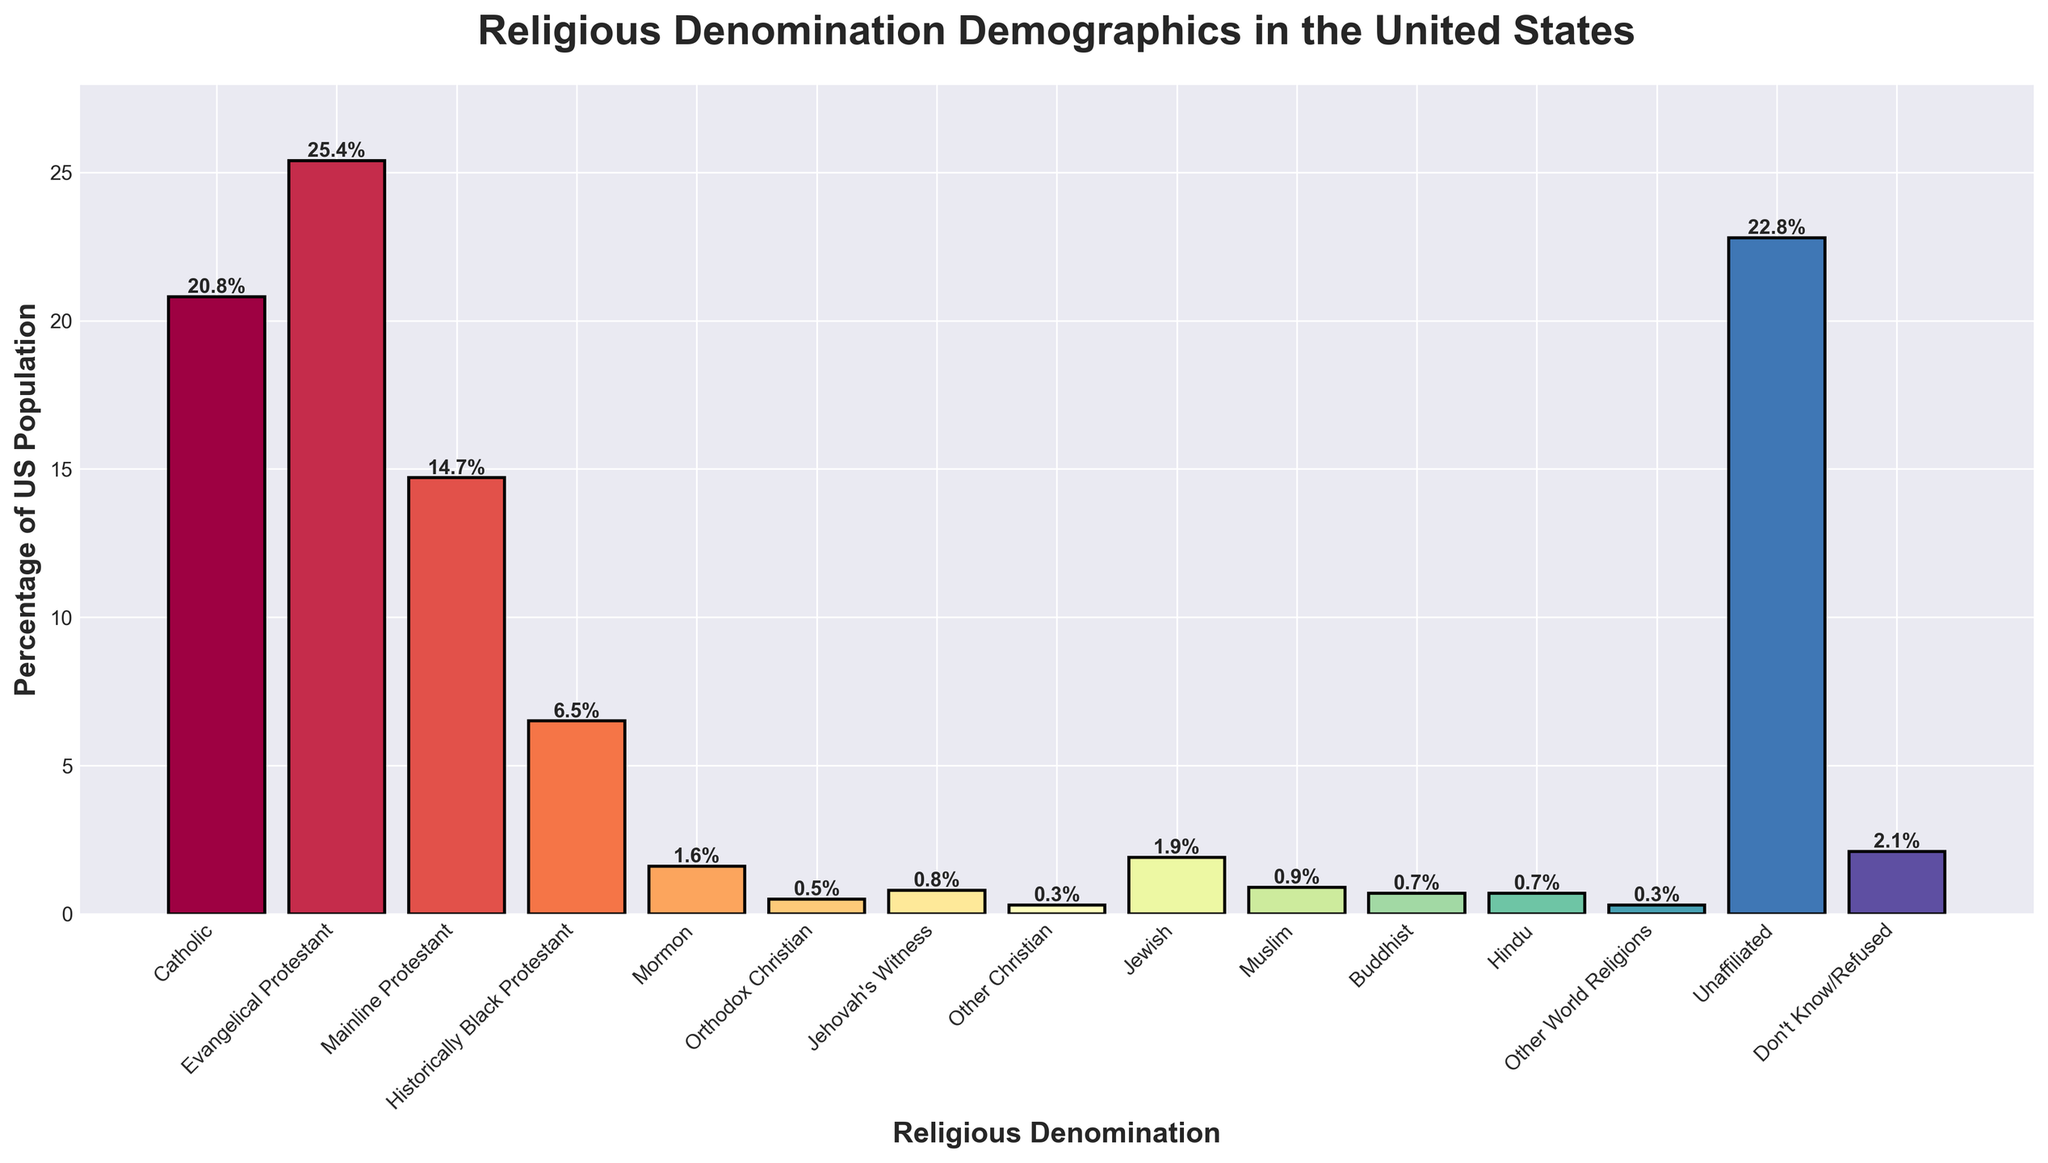What is the most common religious denomination in the United States? The bar with the highest value represents the most common denomination. From the chart, the "Evangelical Protestant" bar has the highest percentage.
Answer: Evangelical Protestant Which denomination has a slightly lower percentage than Catholic? Locate the bar for Catholic and observe the adjacent bars. The "Unaffiliated" category is quite close but marginally lower than Catholic at 22.8%.
Answer: Unaffiliated What is the total percentage of US population represented by Evangelical Protestant, Mainline Protestant, and Historically Black Protestant groups combined? Sum the percentages of these three categories: 25.4% (Evangelical Protestant) + 14.7% (Mainline Protestant) + 6.5% (Historically Black Protestant). This calculation gives the total percentage.
Answer: 46.6% Which denomination's bar has the smallest height? Identify the bar with the lowest height. "Other Christian" has the smallest height at 0.3%.
Answer: Other Christian What is the difference in percentage between the Unaffiliated group and the Mainline Protestant group? Subtract the percentage of Mainline Protestant from Unaffiliated: 22.8% (Unaffiliated) - 14.7% (Mainline Protestant). The difference is 8.1%.
Answer: 8.1% Which religions have a population percentage under 1%? Identify bars with heights less than 1%. The religions are Mormon (1.6%), Orthodox Christian (0.5%), Jehovah's Witness (0.8%), Other Christian (0.3%), Muslim (0.9%), Buddhist (0.7%), Hindu (0.7%), and Other World Religions (0.3%).
Answer: Orthodox Christian, Jehovah's Witness, Other Christian, Muslim, Buddhist, Hindu, Other World Religions What's the height difference between the bar representing Jewish and the bar representing Muslim populations? Subtract the percentage of the Muslim bar from the Jewish bar: 1.9% (Jewish) - 0.9% (Muslim). The height difference is 1.0%.
Answer: 1.0% Which groups combined constitute about half of the US population? Calculate the total percentage for various combinations until it adds up to approximately 50%. Combining Evangelical Protestant (25.4%), Catholic (20.8%), and Unaffiliated (22.8%) exceeds 50%. However, combining Evangelical Protestant (25.4%) and Unaffiliated (22.8%) yields 48.2%, which is very close to half.
Answer: Evangelical Protestant and Unaffiliated 